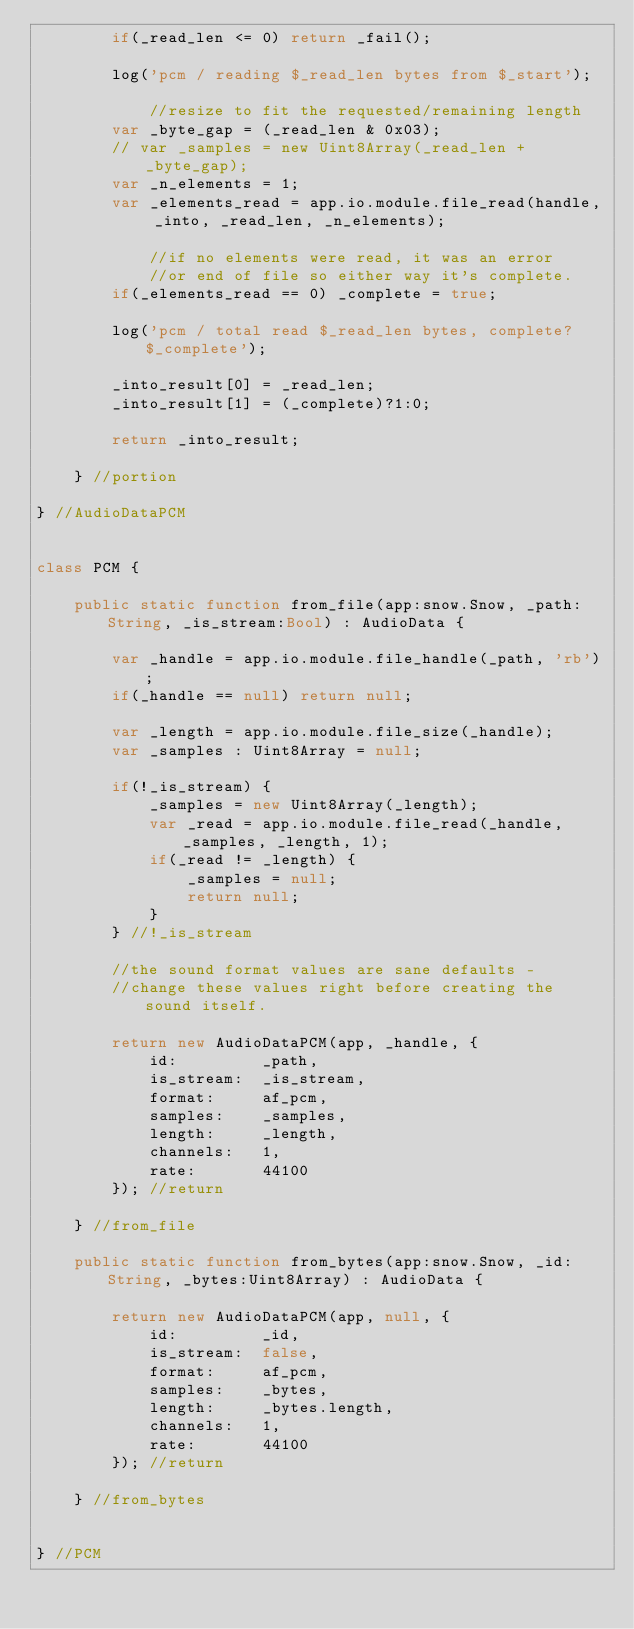<code> <loc_0><loc_0><loc_500><loc_500><_Haxe_>        if(_read_len <= 0) return _fail();

        log('pcm / reading $_read_len bytes from $_start');

            //resize to fit the requested/remaining length
        var _byte_gap = (_read_len & 0x03);
        // var _samples = new Uint8Array(_read_len + _byte_gap);
        var _n_elements = 1;
        var _elements_read = app.io.module.file_read(handle, _into, _read_len, _n_elements);

            //if no elements were read, it was an error
            //or end of file so either way it's complete.
        if(_elements_read == 0) _complete = true;

        log('pcm / total read $_read_len bytes, complete? $_complete');

        _into_result[0] = _read_len;
        _into_result[1] = (_complete)?1:0;

        return _into_result;

    } //portion

} //AudioDataPCM


class PCM {

    public static function from_file(app:snow.Snow, _path:String, _is_stream:Bool) : AudioData {

        var _handle = app.io.module.file_handle(_path, 'rb');
        if(_handle == null) return null;

        var _length = app.io.module.file_size(_handle);
        var _samples : Uint8Array = null;

        if(!_is_stream) {
            _samples = new Uint8Array(_length);
            var _read = app.io.module.file_read(_handle, _samples, _length, 1);
            if(_read != _length) {
                _samples = null;
                return null;
            }
        } //!_is_stream

        //the sound format values are sane defaults -
        //change these values right before creating the sound itself.

        return new AudioDataPCM(app, _handle, {
            id:         _path,
            is_stream:  _is_stream,
            format:     af_pcm,
            samples:    _samples,
            length:     _length,
            channels:   1,
            rate:       44100
        }); //return

    } //from_file

    public static function from_bytes(app:snow.Snow, _id:String, _bytes:Uint8Array) : AudioData {

        return new AudioDataPCM(app, null, {
            id:         _id,
            is_stream:  false,
            format:     af_pcm,
            samples:    _bytes,
            length:     _bytes.length,
            channels:   1,
            rate:       44100
        }); //return

    } //from_bytes


} //PCM
</code> 